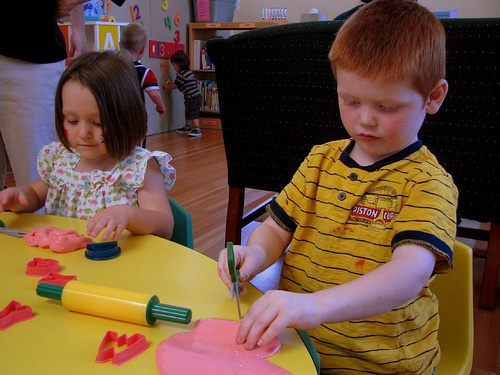Describe the objects in this image and their specific colors. I can see people in black, olive, and maroon tones, dining table in black, olive, tan, orange, and salmon tones, couch in black, gray, and maroon tones, people in black, brown, darkgray, and maroon tones, and people in black, gray, and maroon tones in this image. 